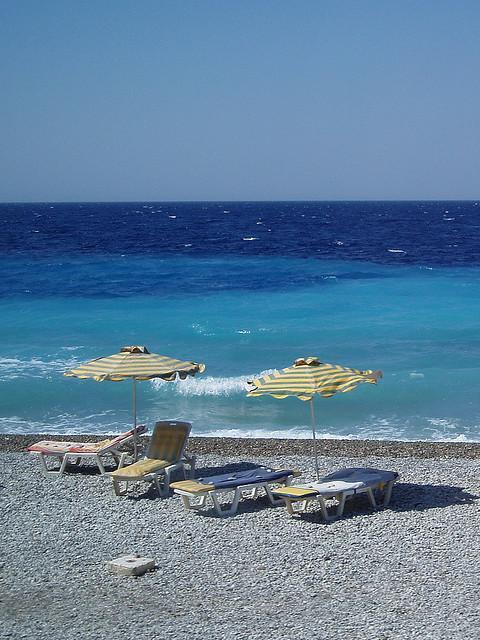How many umbrellas are there?
Give a very brief answer. 2. How many chairs are there?
Give a very brief answer. 3. How many zebras are there?
Give a very brief answer. 0. 